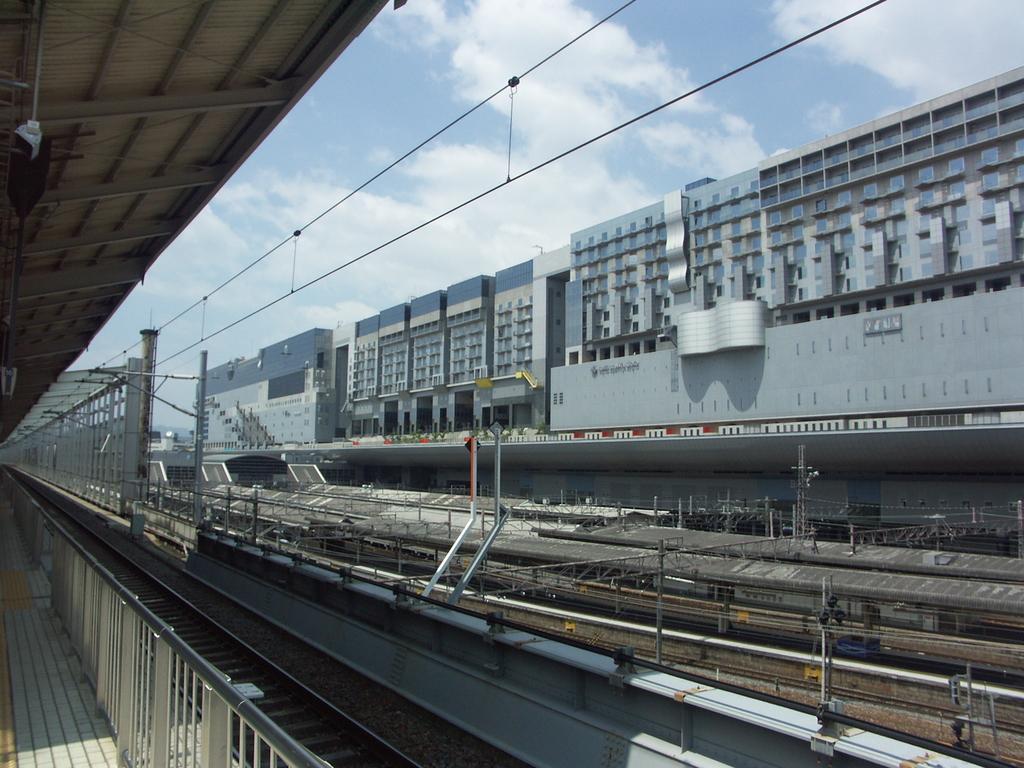Describe this image in one or two sentences. There are railway tracks with electric poles. Also there are railings. In the back there are many buildings. Also there is sky with clouds. 